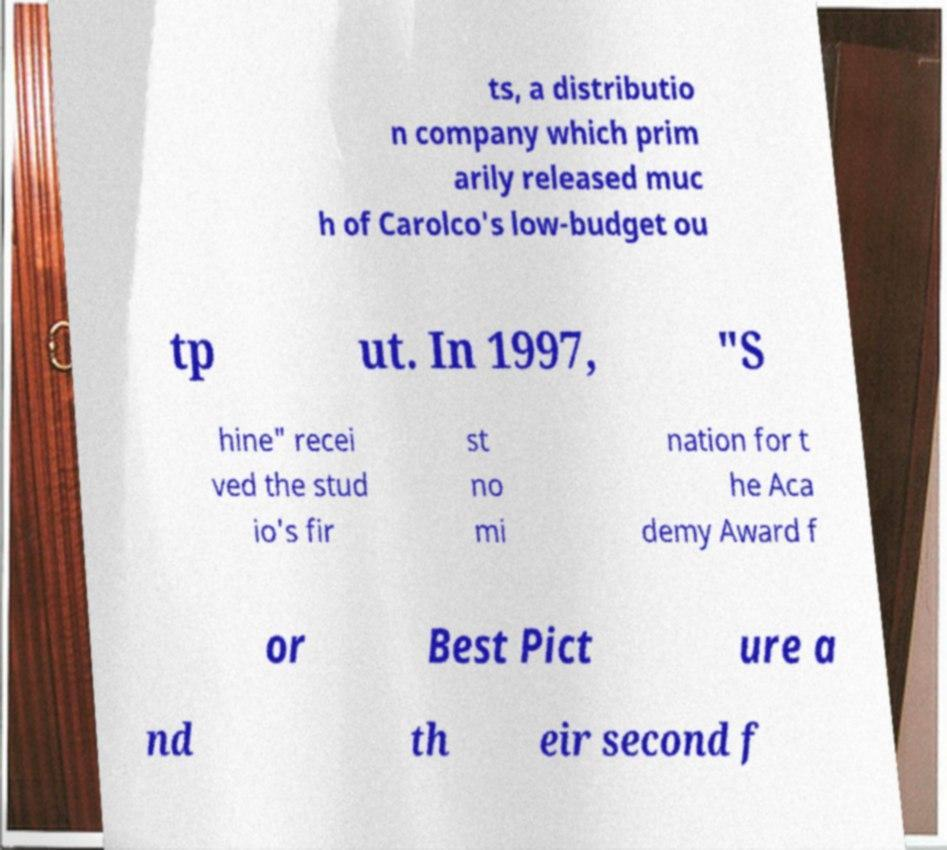Please identify and transcribe the text found in this image. ts, a distributio n company which prim arily released muc h of Carolco's low-budget ou tp ut. In 1997, "S hine" recei ved the stud io's fir st no mi nation for t he Aca demy Award f or Best Pict ure a nd th eir second f 